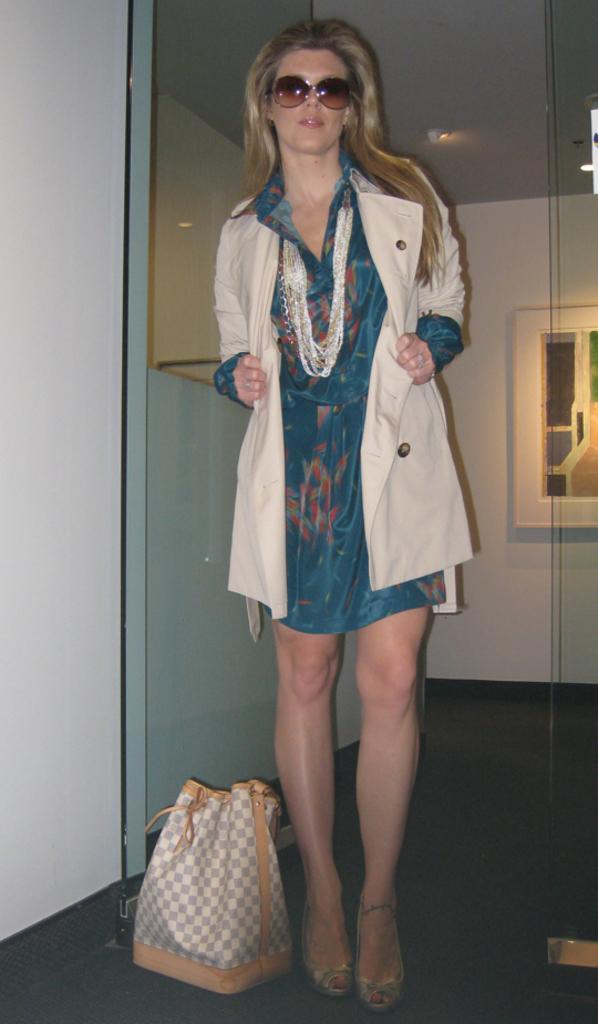In one or two sentences, can you explain what this image depicts? In this image there is a woman standing on the floor. There is a bag beside the woman. At the background there is wall. The woman is wearing jacket and spectacles. 